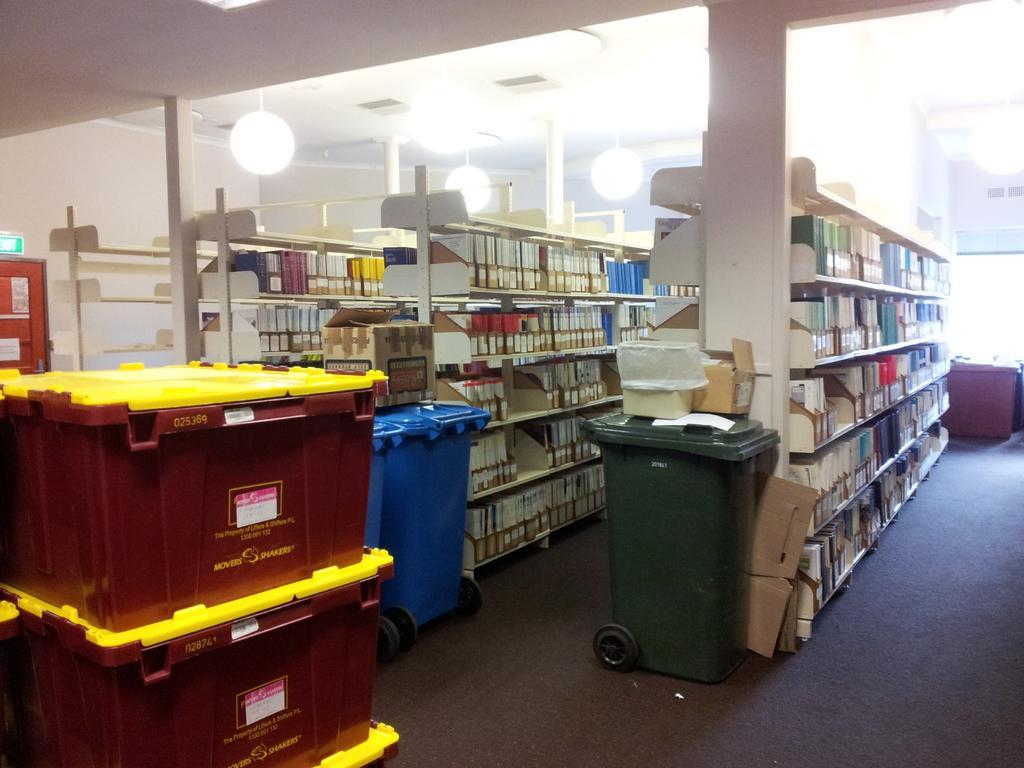Could you give a brief overview of what you see in this image? In this image we can see some containers and cardboard sheets placed on the floor. We can also see some boxes on a container. We can also see some pillars, a group of books and objects placed in the shelves, a door, a signboard and a roof with some ceiling lights. 